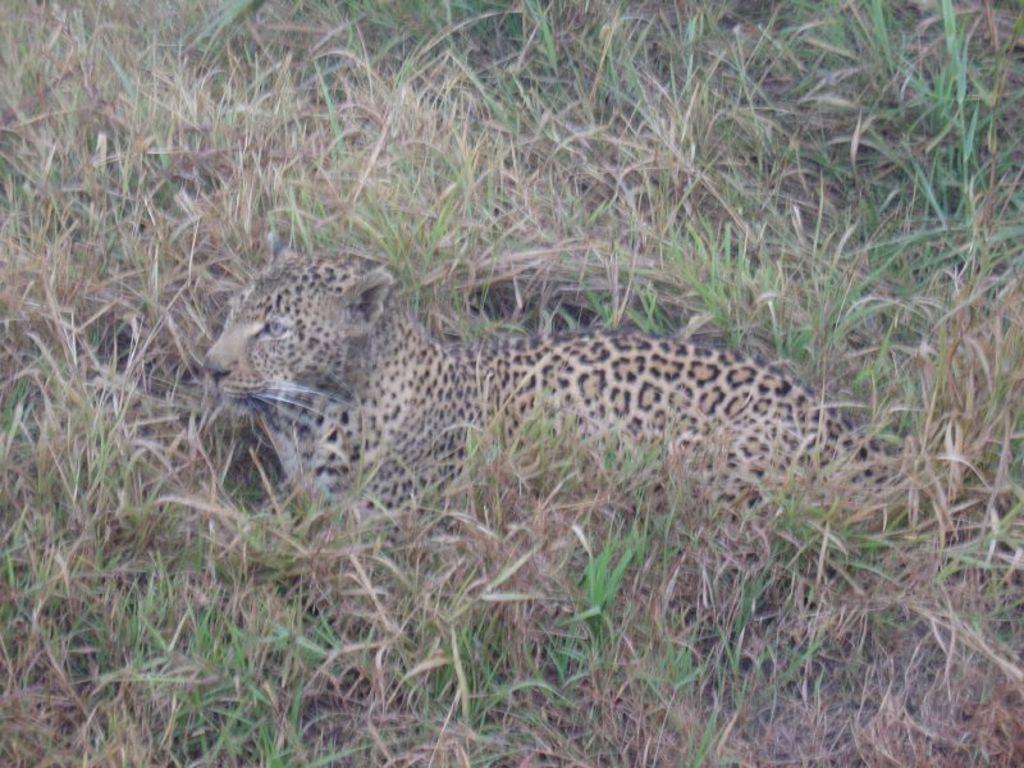Can you describe this image briefly? This picture is clicked outside the city. In the center there is an animal seems to be sitting on the ground and we can see the grass. 